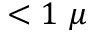Convert formula to latex. <formula><loc_0><loc_0><loc_500><loc_500>< 1 \ \mu</formula> 